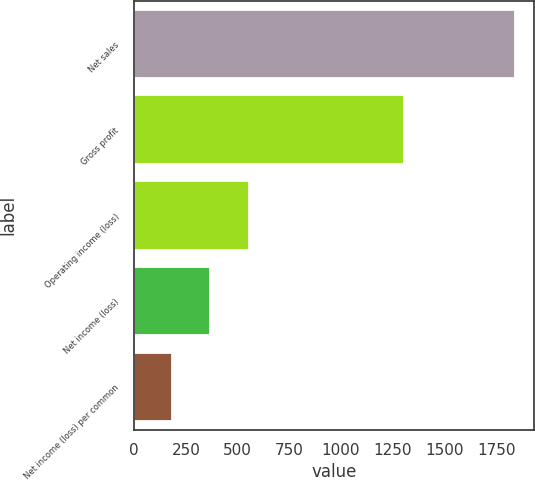Convert chart. <chart><loc_0><loc_0><loc_500><loc_500><bar_chart><fcel>Net sales<fcel>Gross profit<fcel>Operating income (loss)<fcel>Net income (loss)<fcel>Net income (loss) per common<nl><fcel>1843<fcel>1303<fcel>552.95<fcel>368.66<fcel>184.37<nl></chart> 